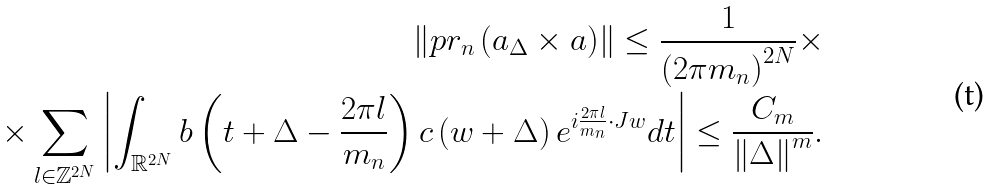<formula> <loc_0><loc_0><loc_500><loc_500>\left \| p r _ { n } \left ( a _ { \Delta } \times a \right ) \right \| \leq \frac { 1 } { \left ( 2 \pi m _ { n } \right ) ^ { 2 N } } \times \\ \times \sum _ { l \in \mathbb { Z } ^ { 2 N } } \left | \int _ { \mathbb { R } ^ { 2 N } } b \left ( t + \Delta - \frac { 2 \pi l } { m _ { n } } \right ) c \left ( w + \Delta \right ) e ^ { i \frac { 2 \pi l } { m _ { n } } \cdot J w } d t \right | \leq \frac { C _ { m } } { \left \| \Delta \right \| ^ { m } } .</formula> 